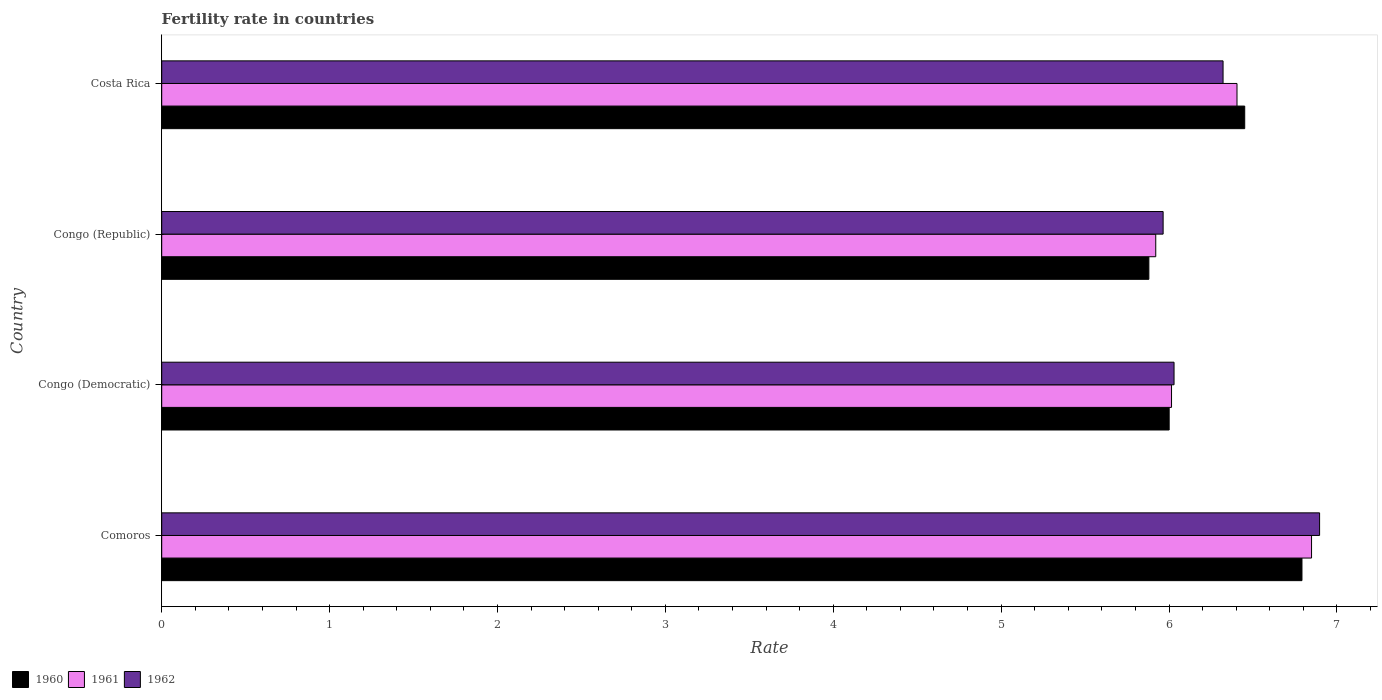How many different coloured bars are there?
Keep it short and to the point. 3. How many groups of bars are there?
Your response must be concise. 4. Are the number of bars on each tick of the Y-axis equal?
Provide a short and direct response. Yes. How many bars are there on the 1st tick from the top?
Your answer should be compact. 3. What is the label of the 3rd group of bars from the top?
Keep it short and to the point. Congo (Democratic). What is the fertility rate in 1960 in Costa Rica?
Ensure brevity in your answer.  6.45. Across all countries, what is the maximum fertility rate in 1960?
Provide a short and direct response. 6.79. Across all countries, what is the minimum fertility rate in 1961?
Provide a short and direct response. 5.92. In which country was the fertility rate in 1960 maximum?
Provide a short and direct response. Comoros. In which country was the fertility rate in 1961 minimum?
Provide a short and direct response. Congo (Republic). What is the total fertility rate in 1961 in the graph?
Keep it short and to the point. 25.19. What is the difference between the fertility rate in 1962 in Comoros and that in Congo (Democratic)?
Your response must be concise. 0.87. What is the difference between the fertility rate in 1962 in Congo (Republic) and the fertility rate in 1960 in Costa Rica?
Offer a very short reply. -0.49. What is the average fertility rate in 1962 per country?
Make the answer very short. 6.3. What is the difference between the fertility rate in 1962 and fertility rate in 1960 in Congo (Republic)?
Provide a short and direct response. 0.08. What is the ratio of the fertility rate in 1960 in Congo (Democratic) to that in Costa Rica?
Your answer should be compact. 0.93. Is the fertility rate in 1961 in Congo (Republic) less than that in Costa Rica?
Keep it short and to the point. Yes. Is the difference between the fertility rate in 1962 in Congo (Democratic) and Congo (Republic) greater than the difference between the fertility rate in 1960 in Congo (Democratic) and Congo (Republic)?
Offer a terse response. No. What is the difference between the highest and the second highest fertility rate in 1961?
Offer a terse response. 0.44. What is the difference between the highest and the lowest fertility rate in 1960?
Your answer should be very brief. 0.91. In how many countries, is the fertility rate in 1960 greater than the average fertility rate in 1960 taken over all countries?
Offer a terse response. 2. What does the 2nd bar from the top in Comoros represents?
Ensure brevity in your answer.  1961. How many bars are there?
Your response must be concise. 12. What is the difference between two consecutive major ticks on the X-axis?
Give a very brief answer. 1. Are the values on the major ticks of X-axis written in scientific E-notation?
Your answer should be very brief. No. Does the graph contain grids?
Offer a terse response. No. Where does the legend appear in the graph?
Offer a very short reply. Bottom left. How are the legend labels stacked?
Your answer should be compact. Horizontal. What is the title of the graph?
Your answer should be compact. Fertility rate in countries. Does "2003" appear as one of the legend labels in the graph?
Your answer should be very brief. No. What is the label or title of the X-axis?
Your answer should be very brief. Rate. What is the Rate of 1960 in Comoros?
Keep it short and to the point. 6.79. What is the Rate of 1961 in Comoros?
Offer a very short reply. 6.85. What is the Rate of 1962 in Comoros?
Make the answer very short. 6.9. What is the Rate of 1960 in Congo (Democratic)?
Your answer should be compact. 6. What is the Rate in 1961 in Congo (Democratic)?
Offer a terse response. 6.01. What is the Rate of 1962 in Congo (Democratic)?
Offer a terse response. 6.03. What is the Rate in 1960 in Congo (Republic)?
Your answer should be very brief. 5.88. What is the Rate in 1961 in Congo (Republic)?
Provide a succinct answer. 5.92. What is the Rate of 1962 in Congo (Republic)?
Give a very brief answer. 5.96. What is the Rate of 1960 in Costa Rica?
Keep it short and to the point. 6.45. What is the Rate of 1961 in Costa Rica?
Provide a succinct answer. 6.41. What is the Rate of 1962 in Costa Rica?
Give a very brief answer. 6.32. Across all countries, what is the maximum Rate of 1960?
Provide a succinct answer. 6.79. Across all countries, what is the maximum Rate of 1961?
Provide a short and direct response. 6.85. Across all countries, what is the maximum Rate in 1962?
Offer a very short reply. 6.9. Across all countries, what is the minimum Rate in 1960?
Ensure brevity in your answer.  5.88. Across all countries, what is the minimum Rate in 1961?
Offer a very short reply. 5.92. Across all countries, what is the minimum Rate in 1962?
Keep it short and to the point. 5.96. What is the total Rate of 1960 in the graph?
Provide a succinct answer. 25.12. What is the total Rate in 1961 in the graph?
Offer a very short reply. 25.19. What is the total Rate in 1962 in the graph?
Provide a short and direct response. 25.21. What is the difference between the Rate in 1960 in Comoros and that in Congo (Democratic)?
Your response must be concise. 0.79. What is the difference between the Rate in 1961 in Comoros and that in Congo (Democratic)?
Offer a terse response. 0.83. What is the difference between the Rate in 1962 in Comoros and that in Congo (Democratic)?
Offer a very short reply. 0.87. What is the difference between the Rate of 1960 in Comoros and that in Congo (Republic)?
Provide a succinct answer. 0.91. What is the difference between the Rate of 1961 in Comoros and that in Congo (Republic)?
Your answer should be compact. 0.93. What is the difference between the Rate in 1962 in Comoros and that in Congo (Republic)?
Offer a terse response. 0.93. What is the difference between the Rate in 1960 in Comoros and that in Costa Rica?
Keep it short and to the point. 0.34. What is the difference between the Rate in 1961 in Comoros and that in Costa Rica?
Your response must be concise. 0.44. What is the difference between the Rate of 1962 in Comoros and that in Costa Rica?
Keep it short and to the point. 0.57. What is the difference between the Rate of 1960 in Congo (Democratic) and that in Congo (Republic)?
Offer a terse response. 0.12. What is the difference between the Rate of 1961 in Congo (Democratic) and that in Congo (Republic)?
Your response must be concise. 0.09. What is the difference between the Rate of 1962 in Congo (Democratic) and that in Congo (Republic)?
Your answer should be very brief. 0.07. What is the difference between the Rate in 1960 in Congo (Democratic) and that in Costa Rica?
Provide a short and direct response. -0.45. What is the difference between the Rate in 1961 in Congo (Democratic) and that in Costa Rica?
Your response must be concise. -0.39. What is the difference between the Rate in 1962 in Congo (Democratic) and that in Costa Rica?
Give a very brief answer. -0.29. What is the difference between the Rate of 1960 in Congo (Republic) and that in Costa Rica?
Make the answer very short. -0.57. What is the difference between the Rate of 1961 in Congo (Republic) and that in Costa Rica?
Provide a short and direct response. -0.48. What is the difference between the Rate in 1962 in Congo (Republic) and that in Costa Rica?
Your answer should be compact. -0.36. What is the difference between the Rate in 1960 in Comoros and the Rate in 1961 in Congo (Democratic)?
Ensure brevity in your answer.  0.78. What is the difference between the Rate of 1960 in Comoros and the Rate of 1962 in Congo (Democratic)?
Make the answer very short. 0.76. What is the difference between the Rate in 1961 in Comoros and the Rate in 1962 in Congo (Democratic)?
Offer a very short reply. 0.82. What is the difference between the Rate of 1960 in Comoros and the Rate of 1961 in Congo (Republic)?
Offer a very short reply. 0.87. What is the difference between the Rate of 1960 in Comoros and the Rate of 1962 in Congo (Republic)?
Make the answer very short. 0.83. What is the difference between the Rate in 1961 in Comoros and the Rate in 1962 in Congo (Republic)?
Your answer should be compact. 0.88. What is the difference between the Rate of 1960 in Comoros and the Rate of 1961 in Costa Rica?
Give a very brief answer. 0.39. What is the difference between the Rate of 1960 in Comoros and the Rate of 1962 in Costa Rica?
Your answer should be compact. 0.47. What is the difference between the Rate in 1961 in Comoros and the Rate in 1962 in Costa Rica?
Ensure brevity in your answer.  0.53. What is the difference between the Rate in 1960 in Congo (Democratic) and the Rate in 1962 in Congo (Republic)?
Give a very brief answer. 0.04. What is the difference between the Rate in 1960 in Congo (Democratic) and the Rate in 1961 in Costa Rica?
Offer a terse response. -0.4. What is the difference between the Rate of 1960 in Congo (Democratic) and the Rate of 1962 in Costa Rica?
Keep it short and to the point. -0.32. What is the difference between the Rate in 1961 in Congo (Democratic) and the Rate in 1962 in Costa Rica?
Provide a succinct answer. -0.31. What is the difference between the Rate of 1960 in Congo (Republic) and the Rate of 1961 in Costa Rica?
Ensure brevity in your answer.  -0.53. What is the difference between the Rate of 1960 in Congo (Republic) and the Rate of 1962 in Costa Rica?
Your answer should be compact. -0.44. What is the difference between the Rate in 1961 in Congo (Republic) and the Rate in 1962 in Costa Rica?
Ensure brevity in your answer.  -0.4. What is the average Rate in 1960 per country?
Ensure brevity in your answer.  6.28. What is the average Rate in 1961 per country?
Make the answer very short. 6.3. What is the average Rate in 1962 per country?
Provide a succinct answer. 6.3. What is the difference between the Rate in 1960 and Rate in 1961 in Comoros?
Keep it short and to the point. -0.06. What is the difference between the Rate in 1960 and Rate in 1962 in Comoros?
Offer a terse response. -0.1. What is the difference between the Rate in 1961 and Rate in 1962 in Comoros?
Your answer should be compact. -0.05. What is the difference between the Rate of 1960 and Rate of 1961 in Congo (Democratic)?
Offer a terse response. -0.01. What is the difference between the Rate in 1960 and Rate in 1962 in Congo (Democratic)?
Make the answer very short. -0.03. What is the difference between the Rate of 1961 and Rate of 1962 in Congo (Democratic)?
Keep it short and to the point. -0.01. What is the difference between the Rate in 1960 and Rate in 1961 in Congo (Republic)?
Keep it short and to the point. -0.04. What is the difference between the Rate of 1960 and Rate of 1962 in Congo (Republic)?
Ensure brevity in your answer.  -0.09. What is the difference between the Rate of 1961 and Rate of 1962 in Congo (Republic)?
Ensure brevity in your answer.  -0.04. What is the difference between the Rate in 1960 and Rate in 1961 in Costa Rica?
Provide a succinct answer. 0.05. What is the difference between the Rate of 1960 and Rate of 1962 in Costa Rica?
Offer a very short reply. 0.13. What is the difference between the Rate in 1961 and Rate in 1962 in Costa Rica?
Ensure brevity in your answer.  0.08. What is the ratio of the Rate of 1960 in Comoros to that in Congo (Democratic)?
Your response must be concise. 1.13. What is the ratio of the Rate in 1961 in Comoros to that in Congo (Democratic)?
Offer a terse response. 1.14. What is the ratio of the Rate in 1962 in Comoros to that in Congo (Democratic)?
Your answer should be very brief. 1.14. What is the ratio of the Rate in 1960 in Comoros to that in Congo (Republic)?
Your answer should be very brief. 1.16. What is the ratio of the Rate of 1961 in Comoros to that in Congo (Republic)?
Offer a terse response. 1.16. What is the ratio of the Rate in 1962 in Comoros to that in Congo (Republic)?
Offer a very short reply. 1.16. What is the ratio of the Rate in 1960 in Comoros to that in Costa Rica?
Keep it short and to the point. 1.05. What is the ratio of the Rate in 1961 in Comoros to that in Costa Rica?
Keep it short and to the point. 1.07. What is the ratio of the Rate in 1962 in Comoros to that in Costa Rica?
Offer a very short reply. 1.09. What is the ratio of the Rate of 1960 in Congo (Democratic) to that in Congo (Republic)?
Your answer should be compact. 1.02. What is the ratio of the Rate of 1961 in Congo (Democratic) to that in Congo (Republic)?
Offer a terse response. 1.02. What is the ratio of the Rate in 1962 in Congo (Democratic) to that in Congo (Republic)?
Your response must be concise. 1.01. What is the ratio of the Rate of 1960 in Congo (Democratic) to that in Costa Rica?
Keep it short and to the point. 0.93. What is the ratio of the Rate of 1961 in Congo (Democratic) to that in Costa Rica?
Give a very brief answer. 0.94. What is the ratio of the Rate of 1962 in Congo (Democratic) to that in Costa Rica?
Your answer should be compact. 0.95. What is the ratio of the Rate in 1960 in Congo (Republic) to that in Costa Rica?
Ensure brevity in your answer.  0.91. What is the ratio of the Rate in 1961 in Congo (Republic) to that in Costa Rica?
Provide a short and direct response. 0.92. What is the ratio of the Rate of 1962 in Congo (Republic) to that in Costa Rica?
Your answer should be very brief. 0.94. What is the difference between the highest and the second highest Rate of 1960?
Your answer should be compact. 0.34. What is the difference between the highest and the second highest Rate of 1961?
Your answer should be very brief. 0.44. What is the difference between the highest and the second highest Rate of 1962?
Your answer should be very brief. 0.57. What is the difference between the highest and the lowest Rate in 1960?
Ensure brevity in your answer.  0.91. What is the difference between the highest and the lowest Rate in 1961?
Your answer should be very brief. 0.93. What is the difference between the highest and the lowest Rate in 1962?
Ensure brevity in your answer.  0.93. 